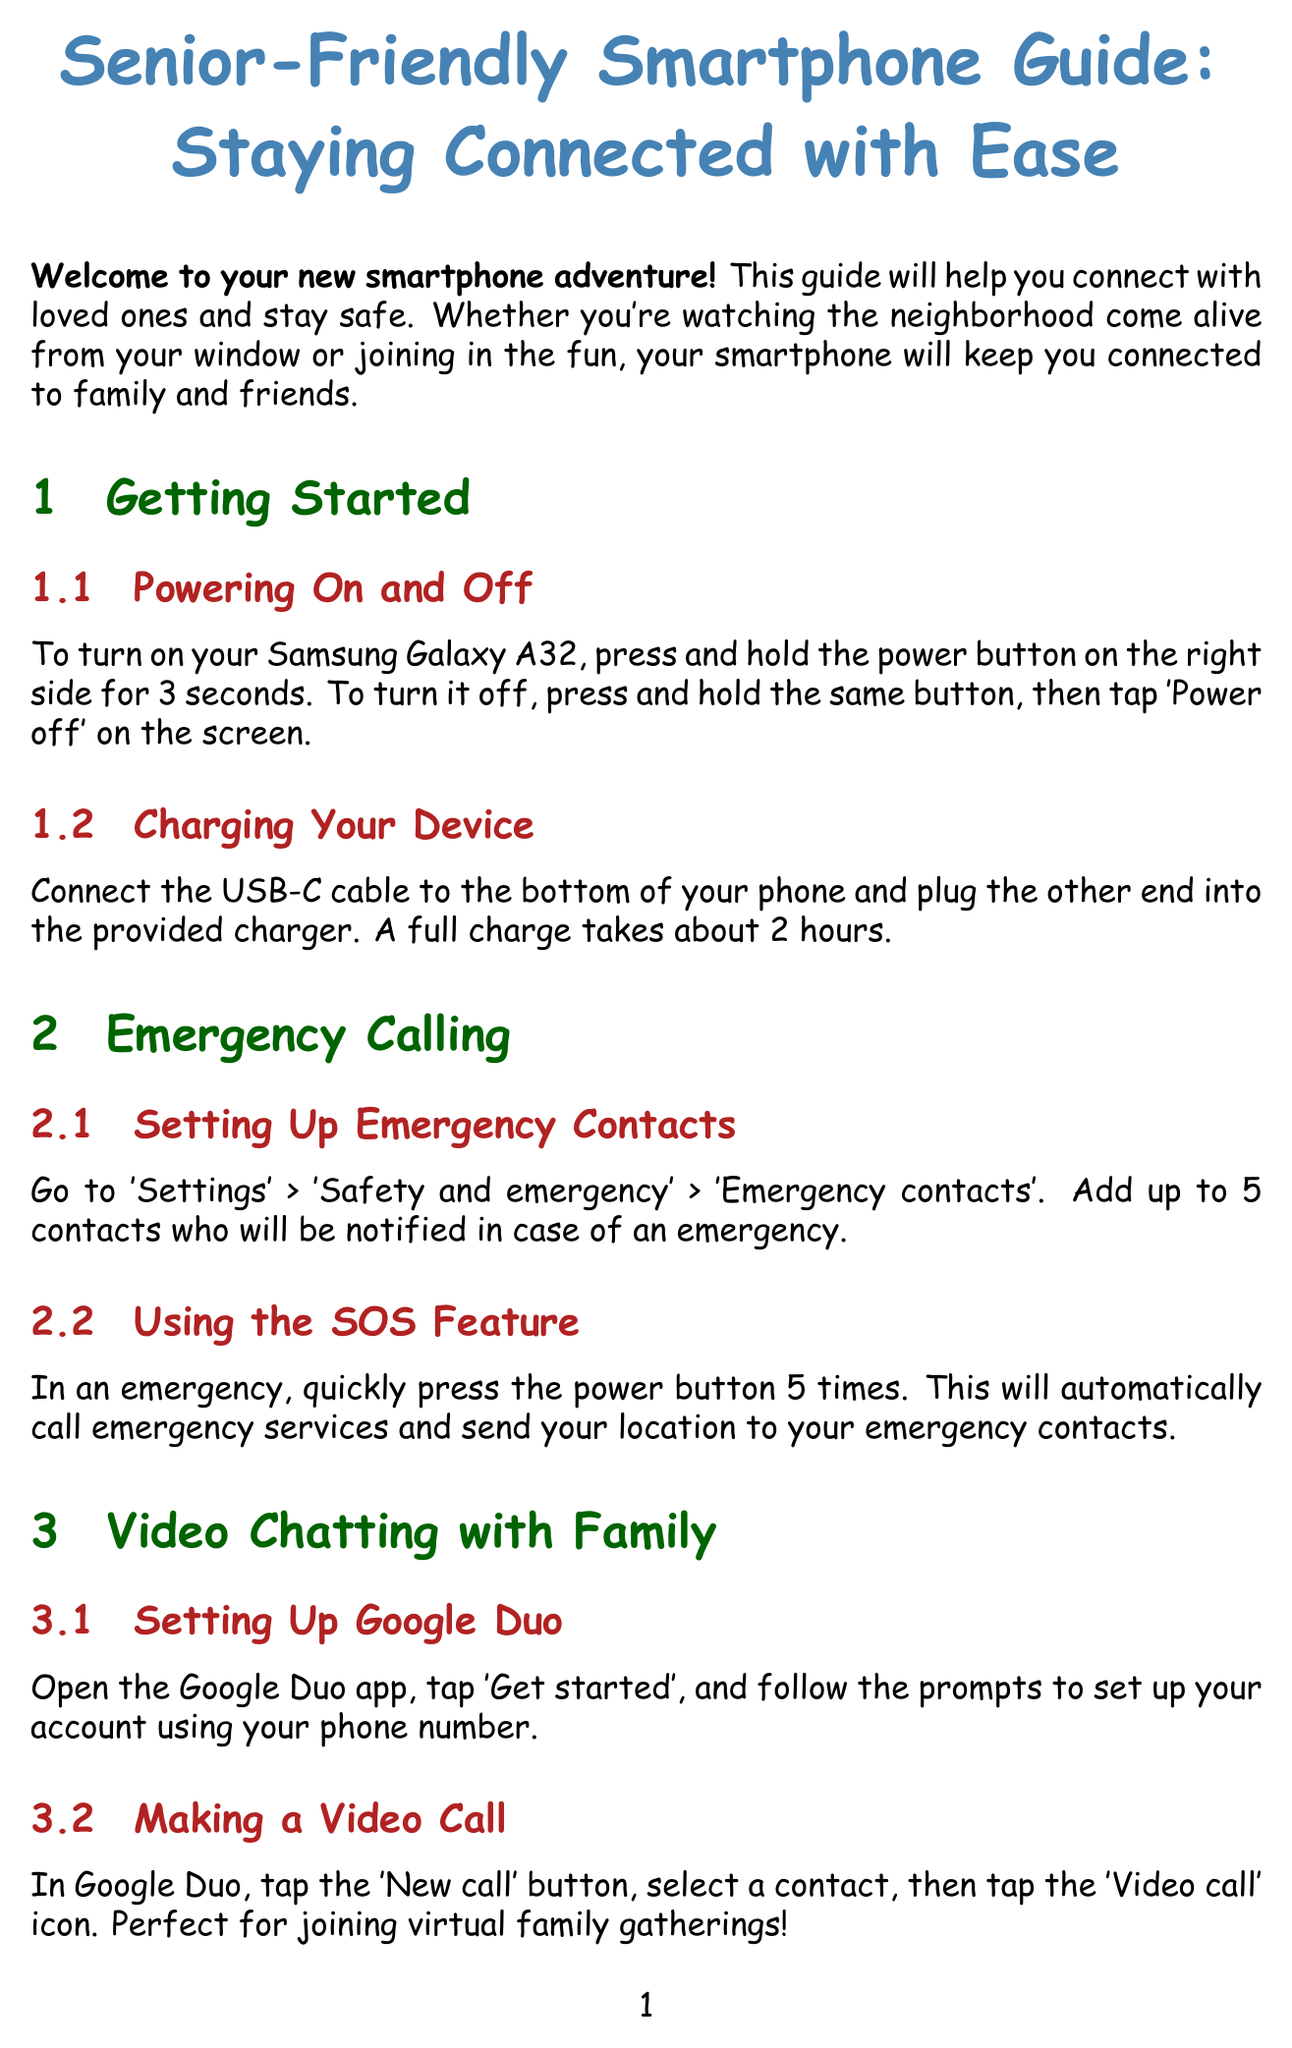what is the manual title? The manual title is the name given to the guide provided in the document.
Answer: Senior-Friendly Smartphone Guide: Staying Connected with Ease how do you turn on the smartphone? This refers to the instruction given for powering on the device in the document.
Answer: Press and hold the power button on the right side for 3 seconds how many emergency contacts can you add? This is the upper limit specified for emergency contacts in the manual.
Answer: Up to 5 contacts how do you call emergency services in an emergency? This specifies the action needed to trigger emergency services as described in the document.
Answer: Quickly press the power button 5 times what app do you use for video chatting? This question identifies the specific application mentioned for video calls.
Answer: Google Duo what should you do to adjust the volume during a call? This refers to the action one must take to control sound levels during a conversation.
Answer: Use the volume buttons on the left side which section helps improve text readability? This refers to the part of the document dedicated to visual enhancements.
Answer: Increasing Text Size how can you enable the voice assistant? This specifies the method to activate the voice assistant feature as per the instructions.
Answer: Say 'Hey Google' or press and hold the home button what is the phone number for senior support? This request seeks the contact information provided for additional assistance.
Answer: 1-800-SENIOR-TECH 